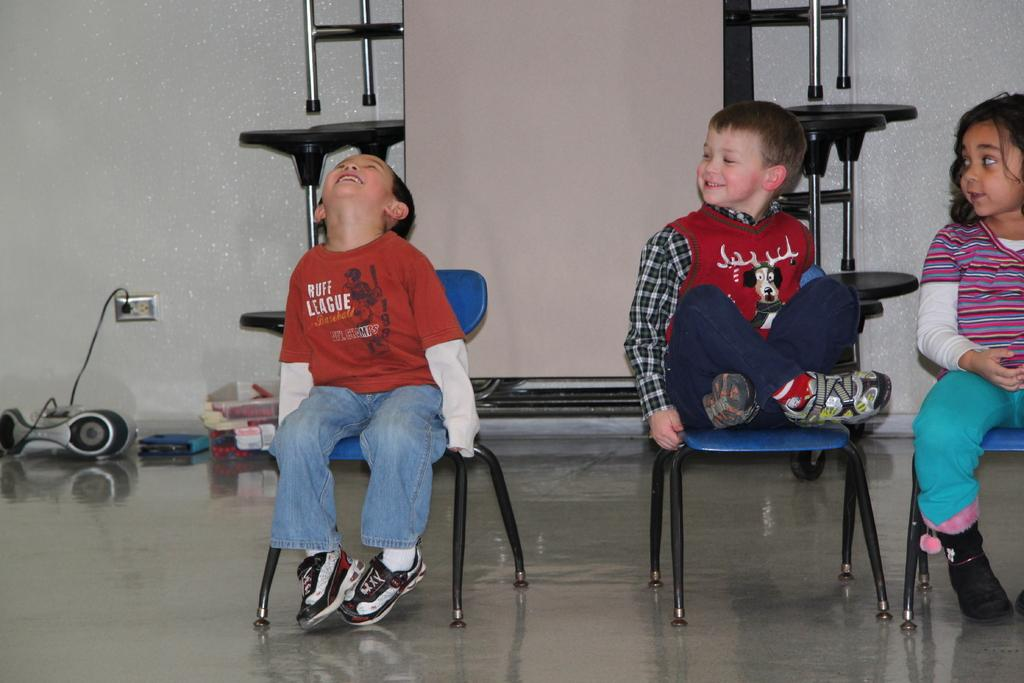How many children are present in the image? There are three children in the image: two boys and one girl. What are the children doing in the image? The children are seated on chairs and smiling. What type of poison is the girl holding in the image? There is no poison present in the image; the children are simply smiling and seated on chairs. 